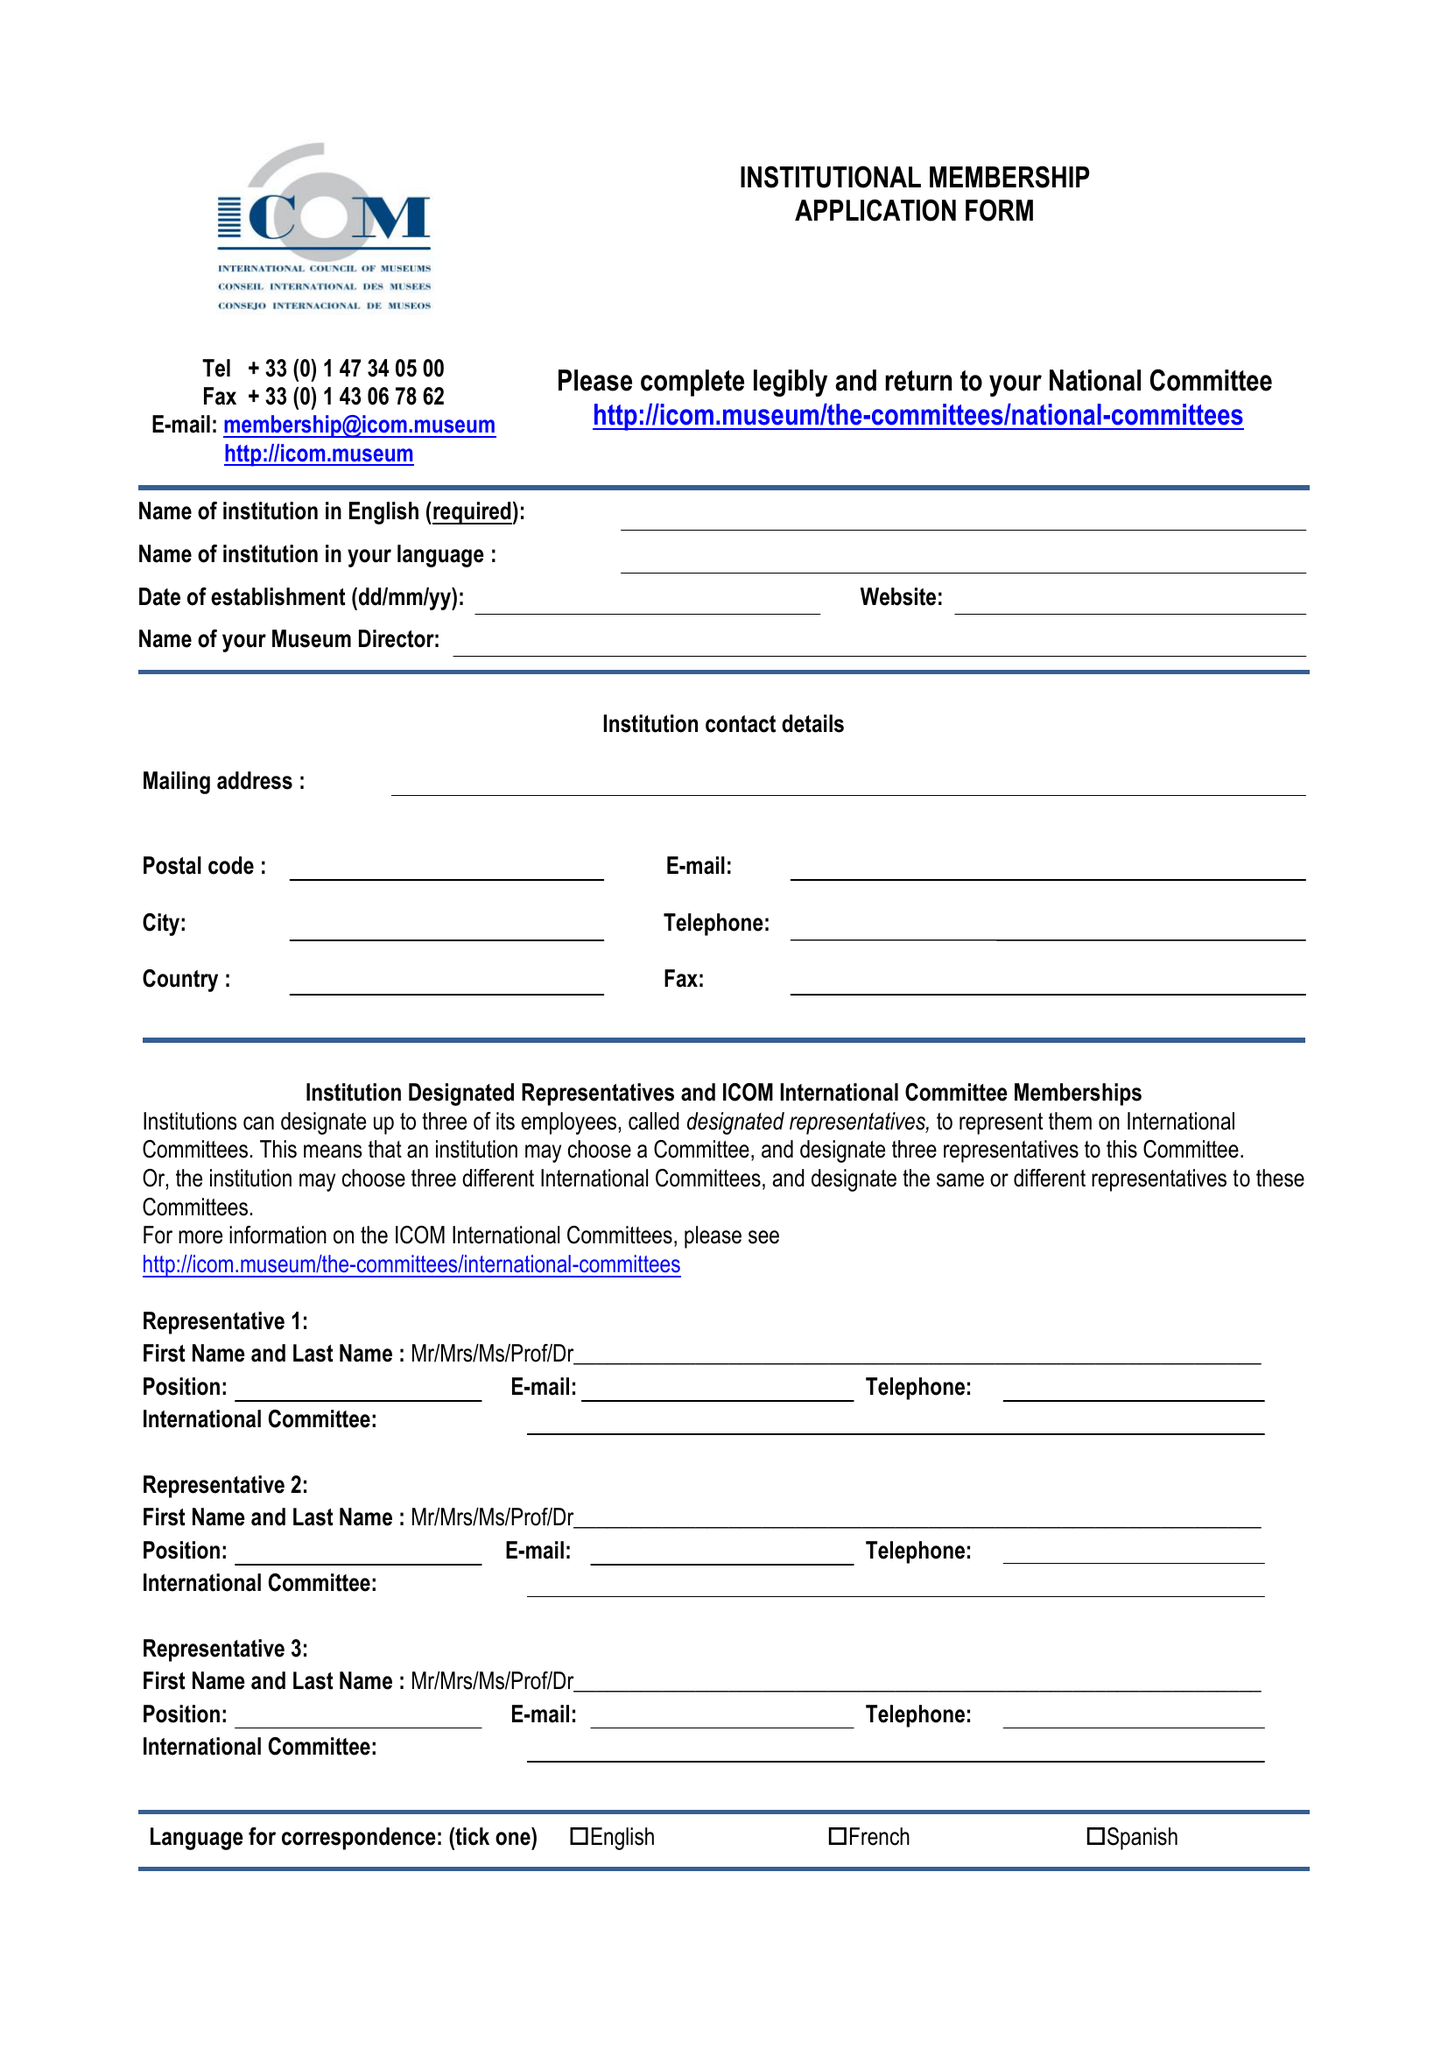What is the value for the address__street_line?
Answer the question using a single word or phrase. 152 CITY ROAD 